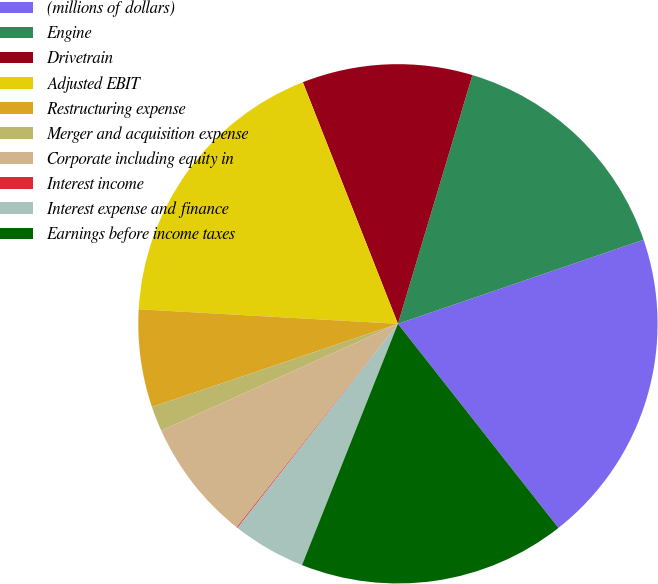<chart> <loc_0><loc_0><loc_500><loc_500><pie_chart><fcel>(millions of dollars)<fcel>Engine<fcel>Drivetrain<fcel>Adjusted EBIT<fcel>Restructuring expense<fcel>Merger and acquisition expense<fcel>Corporate including equity in<fcel>Interest income<fcel>Interest expense and finance<fcel>Earnings before income taxes<nl><fcel>19.64%<fcel>15.12%<fcel>10.6%<fcel>18.14%<fcel>6.08%<fcel>1.56%<fcel>7.59%<fcel>0.06%<fcel>4.58%<fcel>16.63%<nl></chart> 